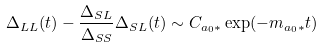Convert formula to latex. <formula><loc_0><loc_0><loc_500><loc_500>\Delta _ { L L } ( t ) - \frac { \Delta _ { S L } } { \Delta _ { S S } } \Delta _ { S L } ( t ) \sim C _ { a _ { 0 } * } \exp ( - m _ { a _ { 0 } * } t )</formula> 